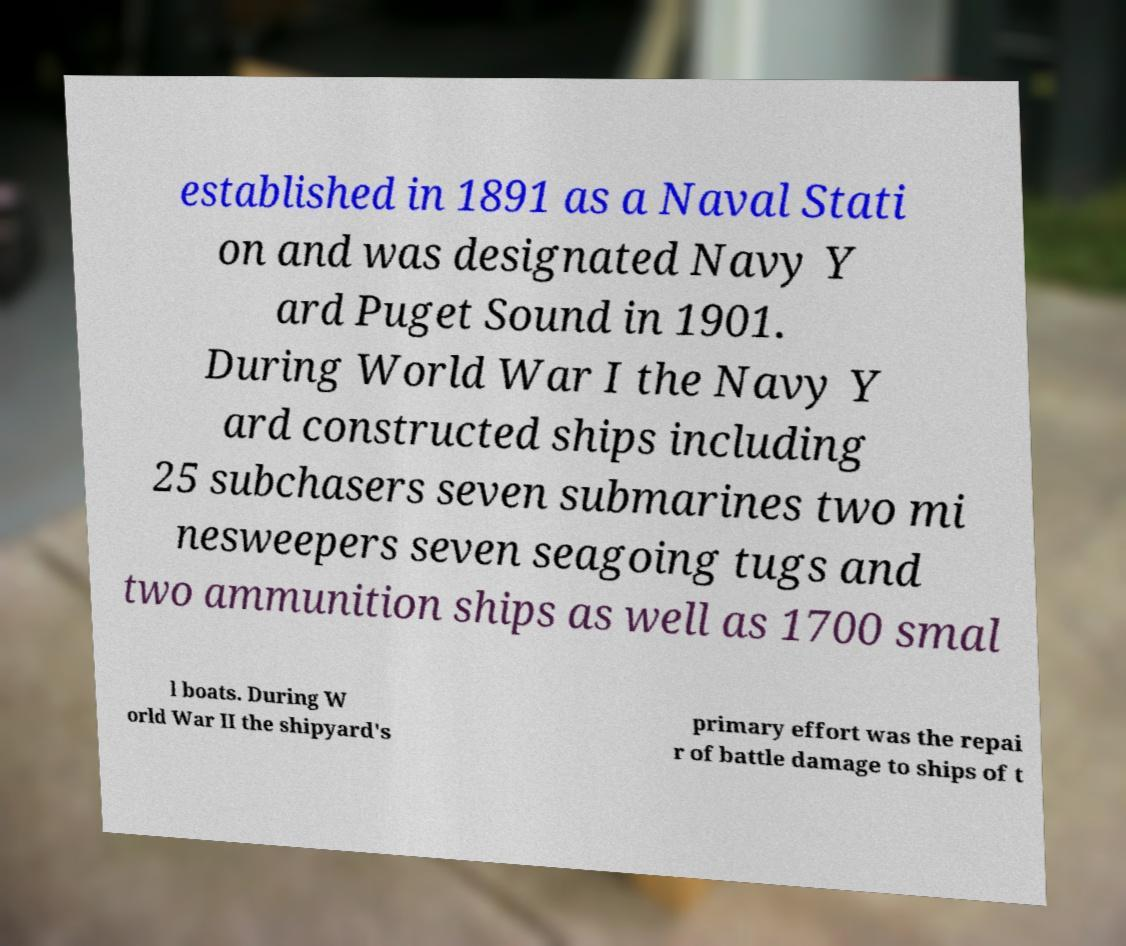There's text embedded in this image that I need extracted. Can you transcribe it verbatim? established in 1891 as a Naval Stati on and was designated Navy Y ard Puget Sound in 1901. During World War I the Navy Y ard constructed ships including 25 subchasers seven submarines two mi nesweepers seven seagoing tugs and two ammunition ships as well as 1700 smal l boats. During W orld War II the shipyard's primary effort was the repai r of battle damage to ships of t 